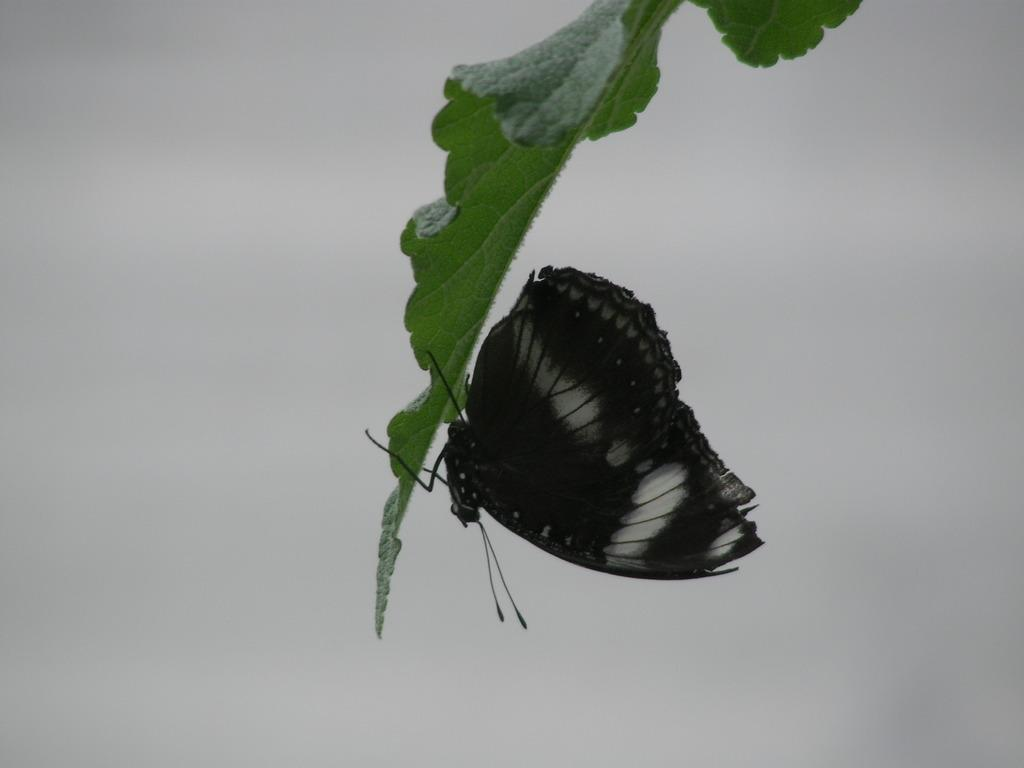What is the main subject of the image? There is a butterfly in the image. Where is the butterfly located? The butterfly is on a green leaf. What color is the background of the image? The background of the image is white. How many cards can be seen in the image? There are no cards present in the image; it features a butterfly on a green leaf with a white background. 